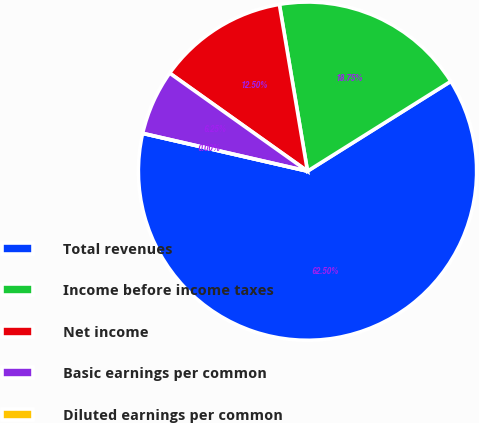Convert chart to OTSL. <chart><loc_0><loc_0><loc_500><loc_500><pie_chart><fcel>Total revenues<fcel>Income before income taxes<fcel>Net income<fcel>Basic earnings per common<fcel>Diluted earnings per common<nl><fcel>62.5%<fcel>18.75%<fcel>12.5%<fcel>6.25%<fcel>0.0%<nl></chart> 